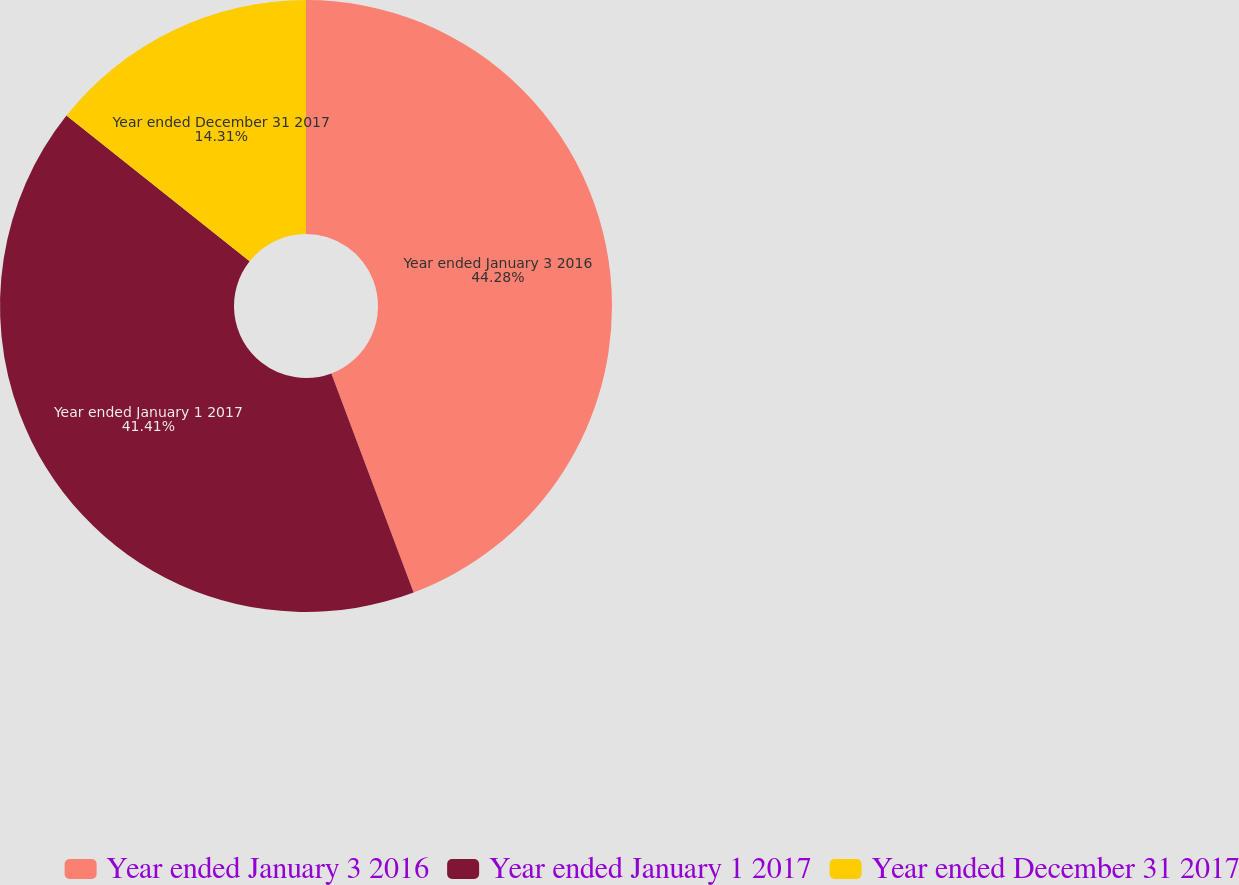Convert chart. <chart><loc_0><loc_0><loc_500><loc_500><pie_chart><fcel>Year ended January 3 2016<fcel>Year ended January 1 2017<fcel>Year ended December 31 2017<nl><fcel>44.28%<fcel>41.41%<fcel>14.31%<nl></chart> 